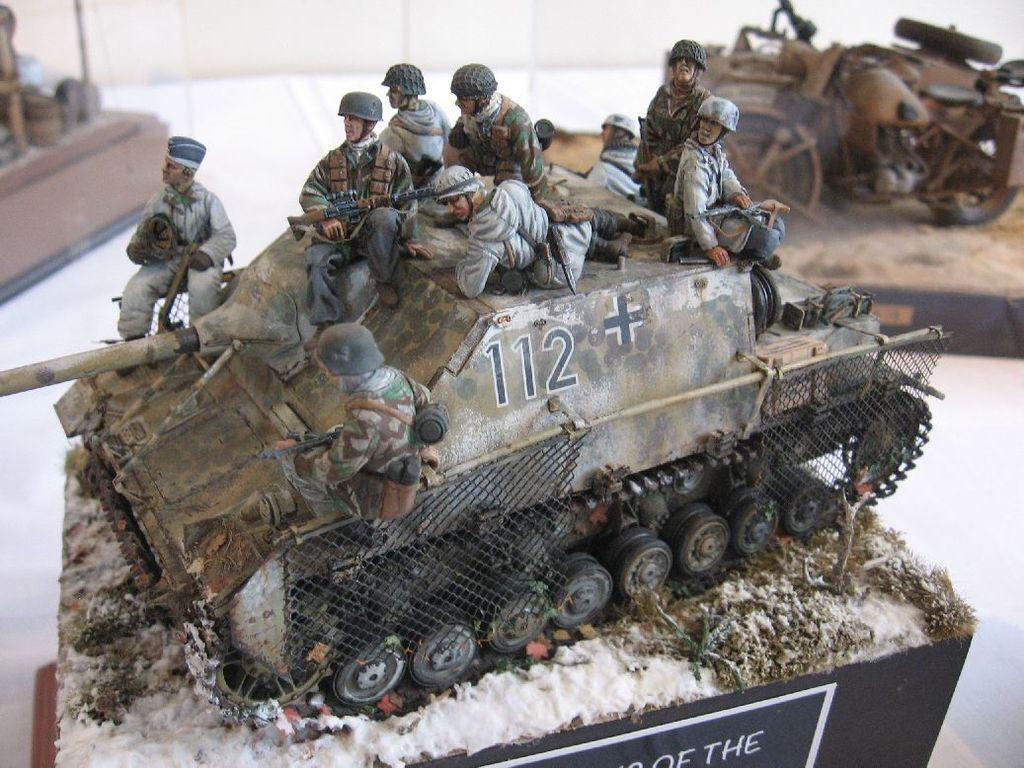Can you describe this image briefly? In the is image we can see a military tank and few vehicle and persons models are displayed. There is a description board in the image. 